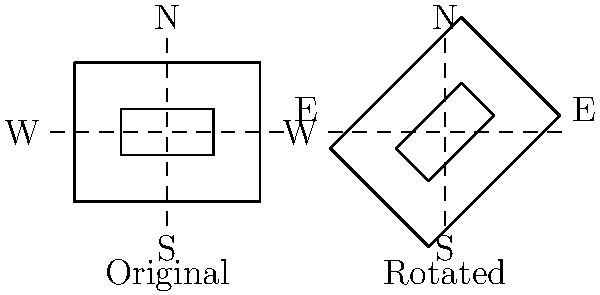A luxury apartment complex in Ho Chi Minh City needs to maximize natural sunlight exposure for its units. The original floor plan is oriented with its long side facing East-West. To improve sunlight exposure, the building needs to be rotated so that its long side faces Northeast-Southwest. By how many degrees should the floor plan be rotated clockwise to achieve this orientation? Let's approach this step-by-step:

1. In the original orientation, the long side of the building faces East-West.

2. We need to rotate the building so that its long side faces Northeast-Southwest.

3. On a compass, Northeast is at a 45-degree angle from North (or East).

4. To move from East-West to Northeast-Southwest, we need to rotate the building by half of this angle.

5. Therefore, the rotation needed is 45/2 = 22.5 degrees.

6. The question asks for a clockwise rotation. Rotating clockwise by 22.5 degrees will align the long side of the building from East-West to Northeast-Southwest.

7. This rotation will maximize sunlight exposure by allowing more surfaces of the building to receive direct sunlight throughout the day, which is crucial for energy efficiency and resident comfort in Vietnam's tropical climate.
Answer: 22.5 degrees clockwise 